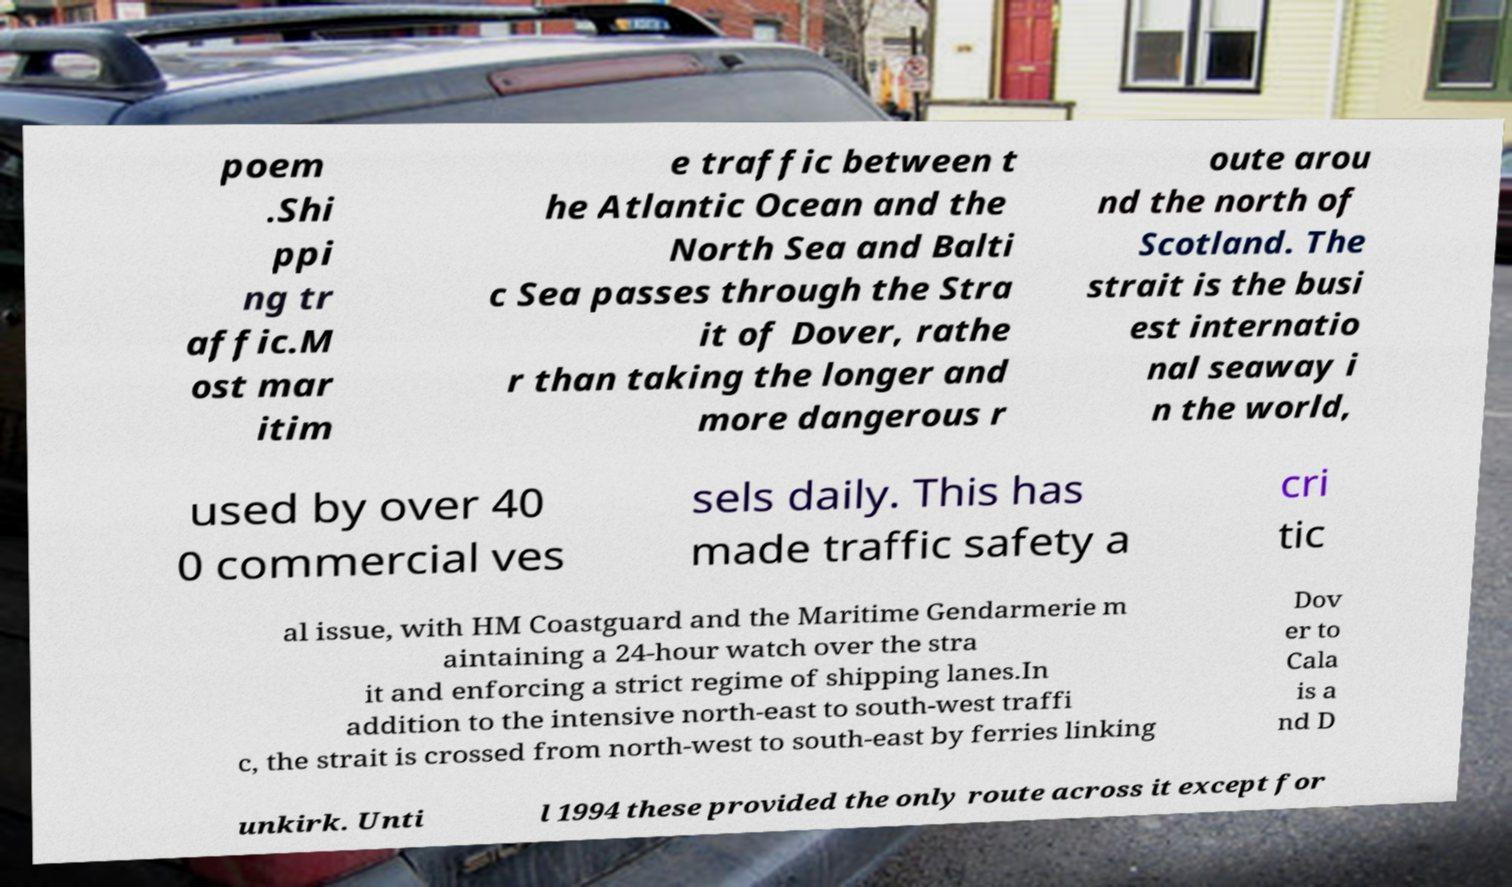What messages or text are displayed in this image? I need them in a readable, typed format. poem .Shi ppi ng tr affic.M ost mar itim e traffic between t he Atlantic Ocean and the North Sea and Balti c Sea passes through the Stra it of Dover, rathe r than taking the longer and more dangerous r oute arou nd the north of Scotland. The strait is the busi est internatio nal seaway i n the world, used by over 40 0 commercial ves sels daily. This has made traffic safety a cri tic al issue, with HM Coastguard and the Maritime Gendarmerie m aintaining a 24-hour watch over the stra it and enforcing a strict regime of shipping lanes.In addition to the intensive north-east to south-west traffi c, the strait is crossed from north-west to south-east by ferries linking Dov er to Cala is a nd D unkirk. Unti l 1994 these provided the only route across it except for 